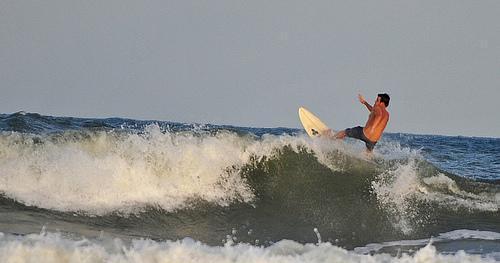How many people are in surfing?
Give a very brief answer. 1. 